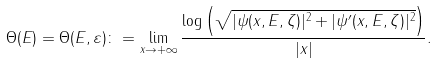<formula> <loc_0><loc_0><loc_500><loc_500>\Theta ( E ) = \Theta ( E , \varepsilon ) \colon = \lim _ { x \to + \infty } \frac { \log \left ( \sqrt { | \psi ( x , E , \zeta ) | ^ { 2 } + | \psi ^ { \prime } ( x , E , \zeta ) | ^ { 2 } } \right ) } { | x | } .</formula> 